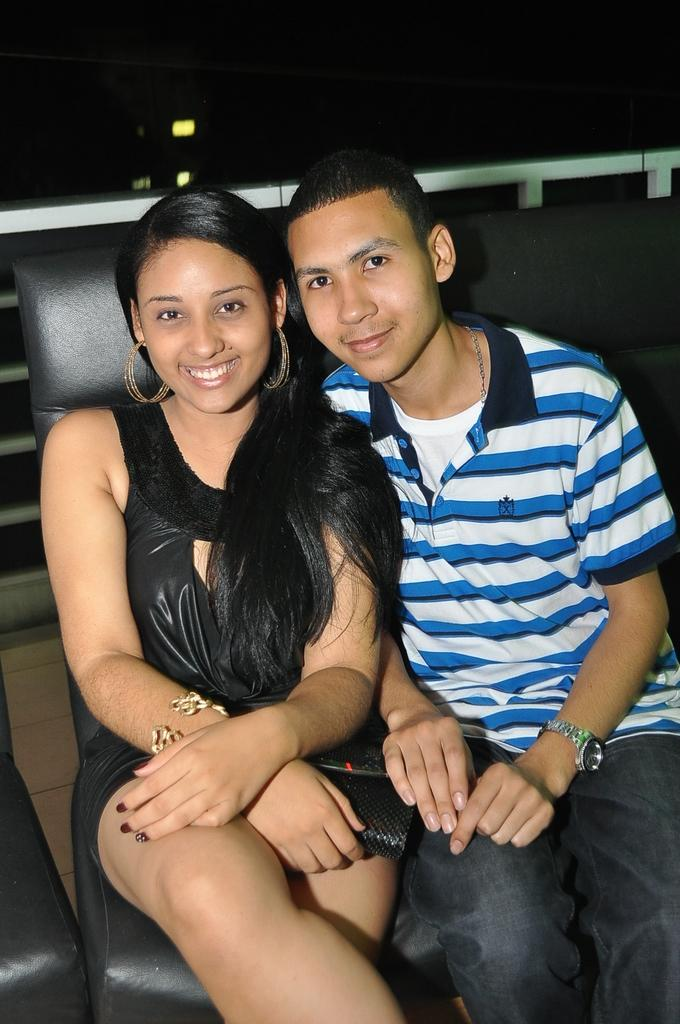Who are the people in the image? There is a girl and a boy in the image. What are they doing in the image? Both the girl and the boy are sitting on a sofa. What expression do they have? The girl and the boy are smiling. What is the mass of the worm crawling on the sofa in the image? There is no worm present in the image, so it is not possible to determine its mass. 